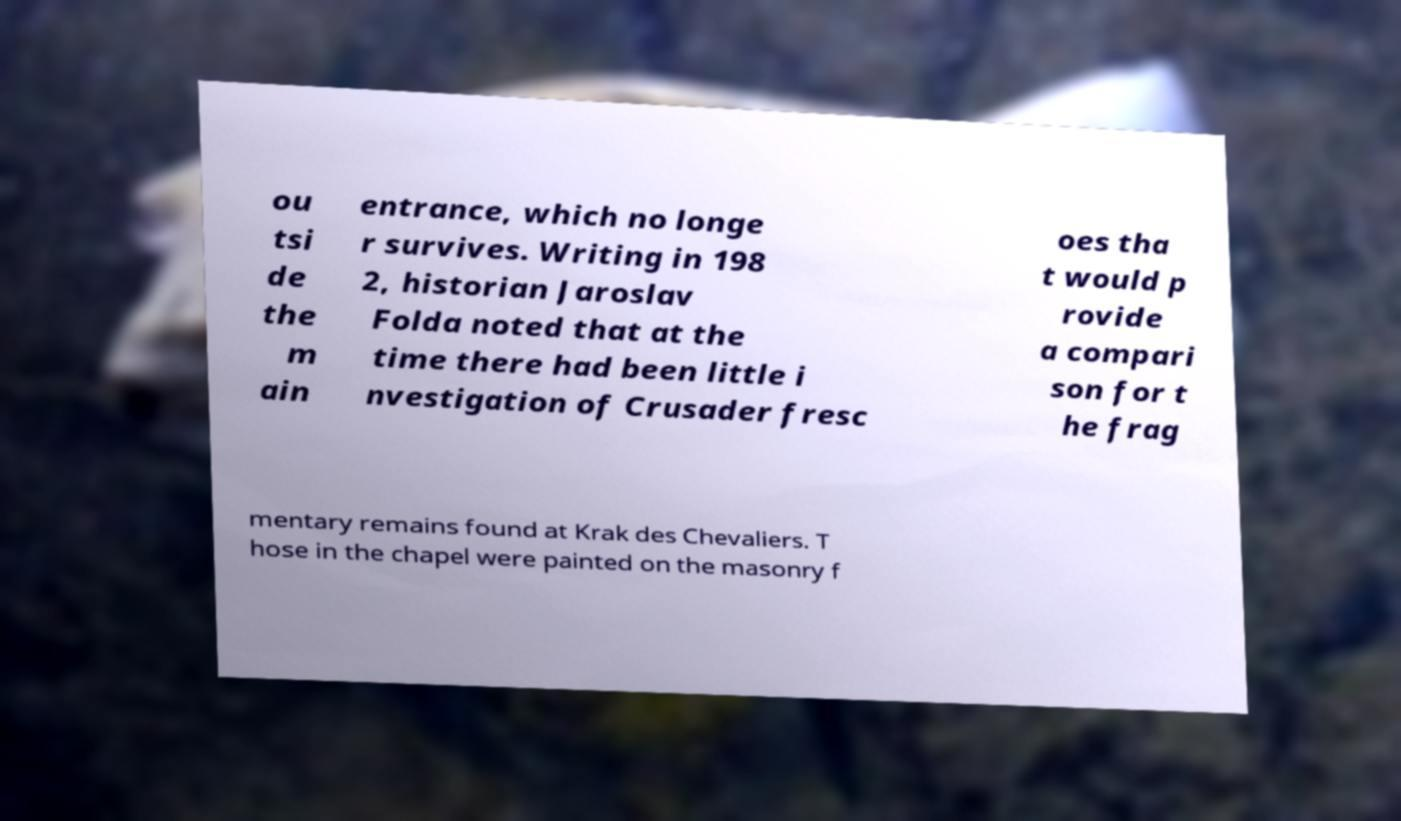For documentation purposes, I need the text within this image transcribed. Could you provide that? ou tsi de the m ain entrance, which no longe r survives. Writing in 198 2, historian Jaroslav Folda noted that at the time there had been little i nvestigation of Crusader fresc oes tha t would p rovide a compari son for t he frag mentary remains found at Krak des Chevaliers. T hose in the chapel were painted on the masonry f 